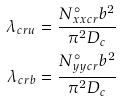<formula> <loc_0><loc_0><loc_500><loc_500>\lambda _ { c r u } & = \frac { N _ { x x c r } ^ { \circ } b ^ { 2 } } { \pi ^ { 2 } D _ { c } } \\ \lambda _ { c r b } & = \frac { N _ { y y c r } ^ { \circ } b ^ { 2 } } { \pi ^ { 2 } D _ { c } }</formula> 